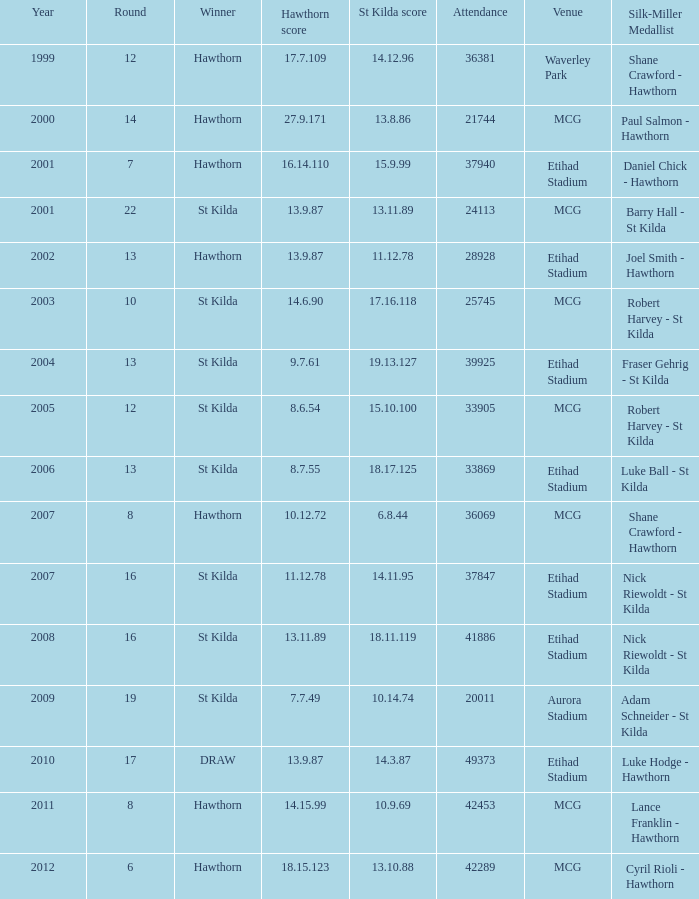What is the number of attendees when the hawthorn score is 1 42289.0. 